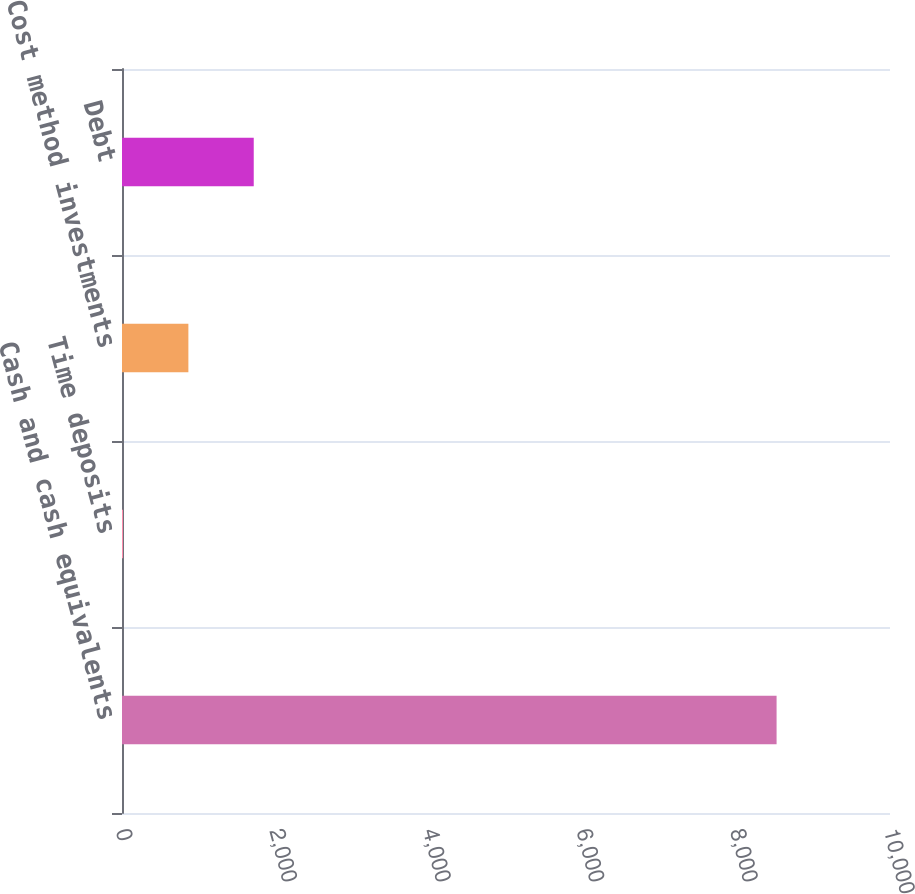<chart> <loc_0><loc_0><loc_500><loc_500><bar_chart><fcel>Cash and cash equivalents<fcel>Time deposits<fcel>Cost method investments<fcel>Debt<nl><fcel>8523.3<fcel>13.4<fcel>864.39<fcel>1715.38<nl></chart> 